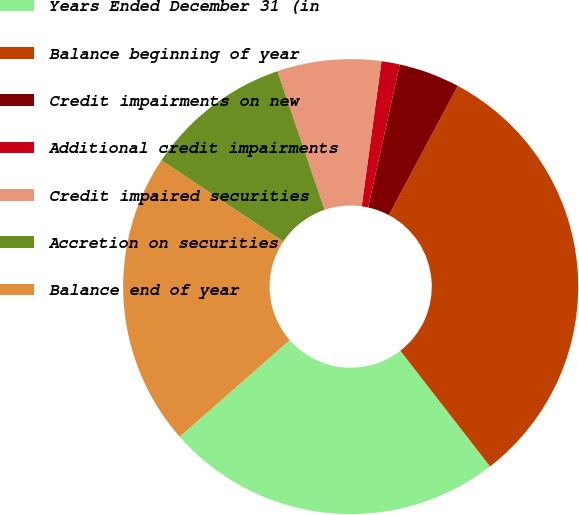Convert chart. <chart><loc_0><loc_0><loc_500><loc_500><pie_chart><fcel>Years Ended December 31 (in<fcel>Balance beginning of year<fcel>Credit impairments on new<fcel>Additional credit impairments<fcel>Credit impaired securities<fcel>Accretion on securities<fcel>Balance end of year<nl><fcel>24.03%<fcel>31.7%<fcel>4.34%<fcel>1.3%<fcel>7.38%<fcel>10.42%<fcel>20.83%<nl></chart> 